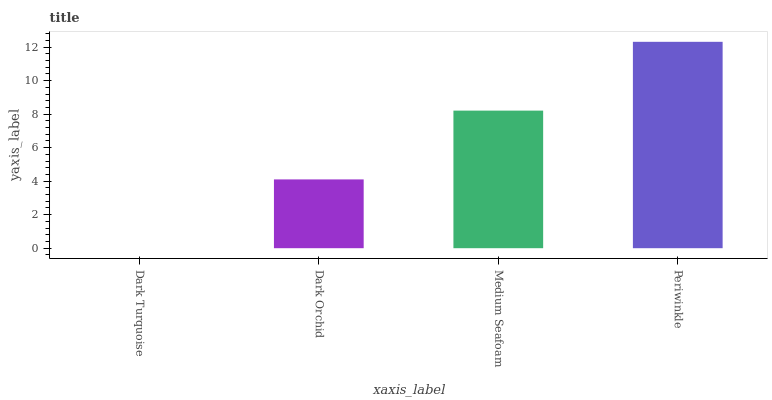Is Dark Turquoise the minimum?
Answer yes or no. Yes. Is Periwinkle the maximum?
Answer yes or no. Yes. Is Dark Orchid the minimum?
Answer yes or no. No. Is Dark Orchid the maximum?
Answer yes or no. No. Is Dark Orchid greater than Dark Turquoise?
Answer yes or no. Yes. Is Dark Turquoise less than Dark Orchid?
Answer yes or no. Yes. Is Dark Turquoise greater than Dark Orchid?
Answer yes or no. No. Is Dark Orchid less than Dark Turquoise?
Answer yes or no. No. Is Medium Seafoam the high median?
Answer yes or no. Yes. Is Dark Orchid the low median?
Answer yes or no. Yes. Is Dark Orchid the high median?
Answer yes or no. No. Is Dark Turquoise the low median?
Answer yes or no. No. 